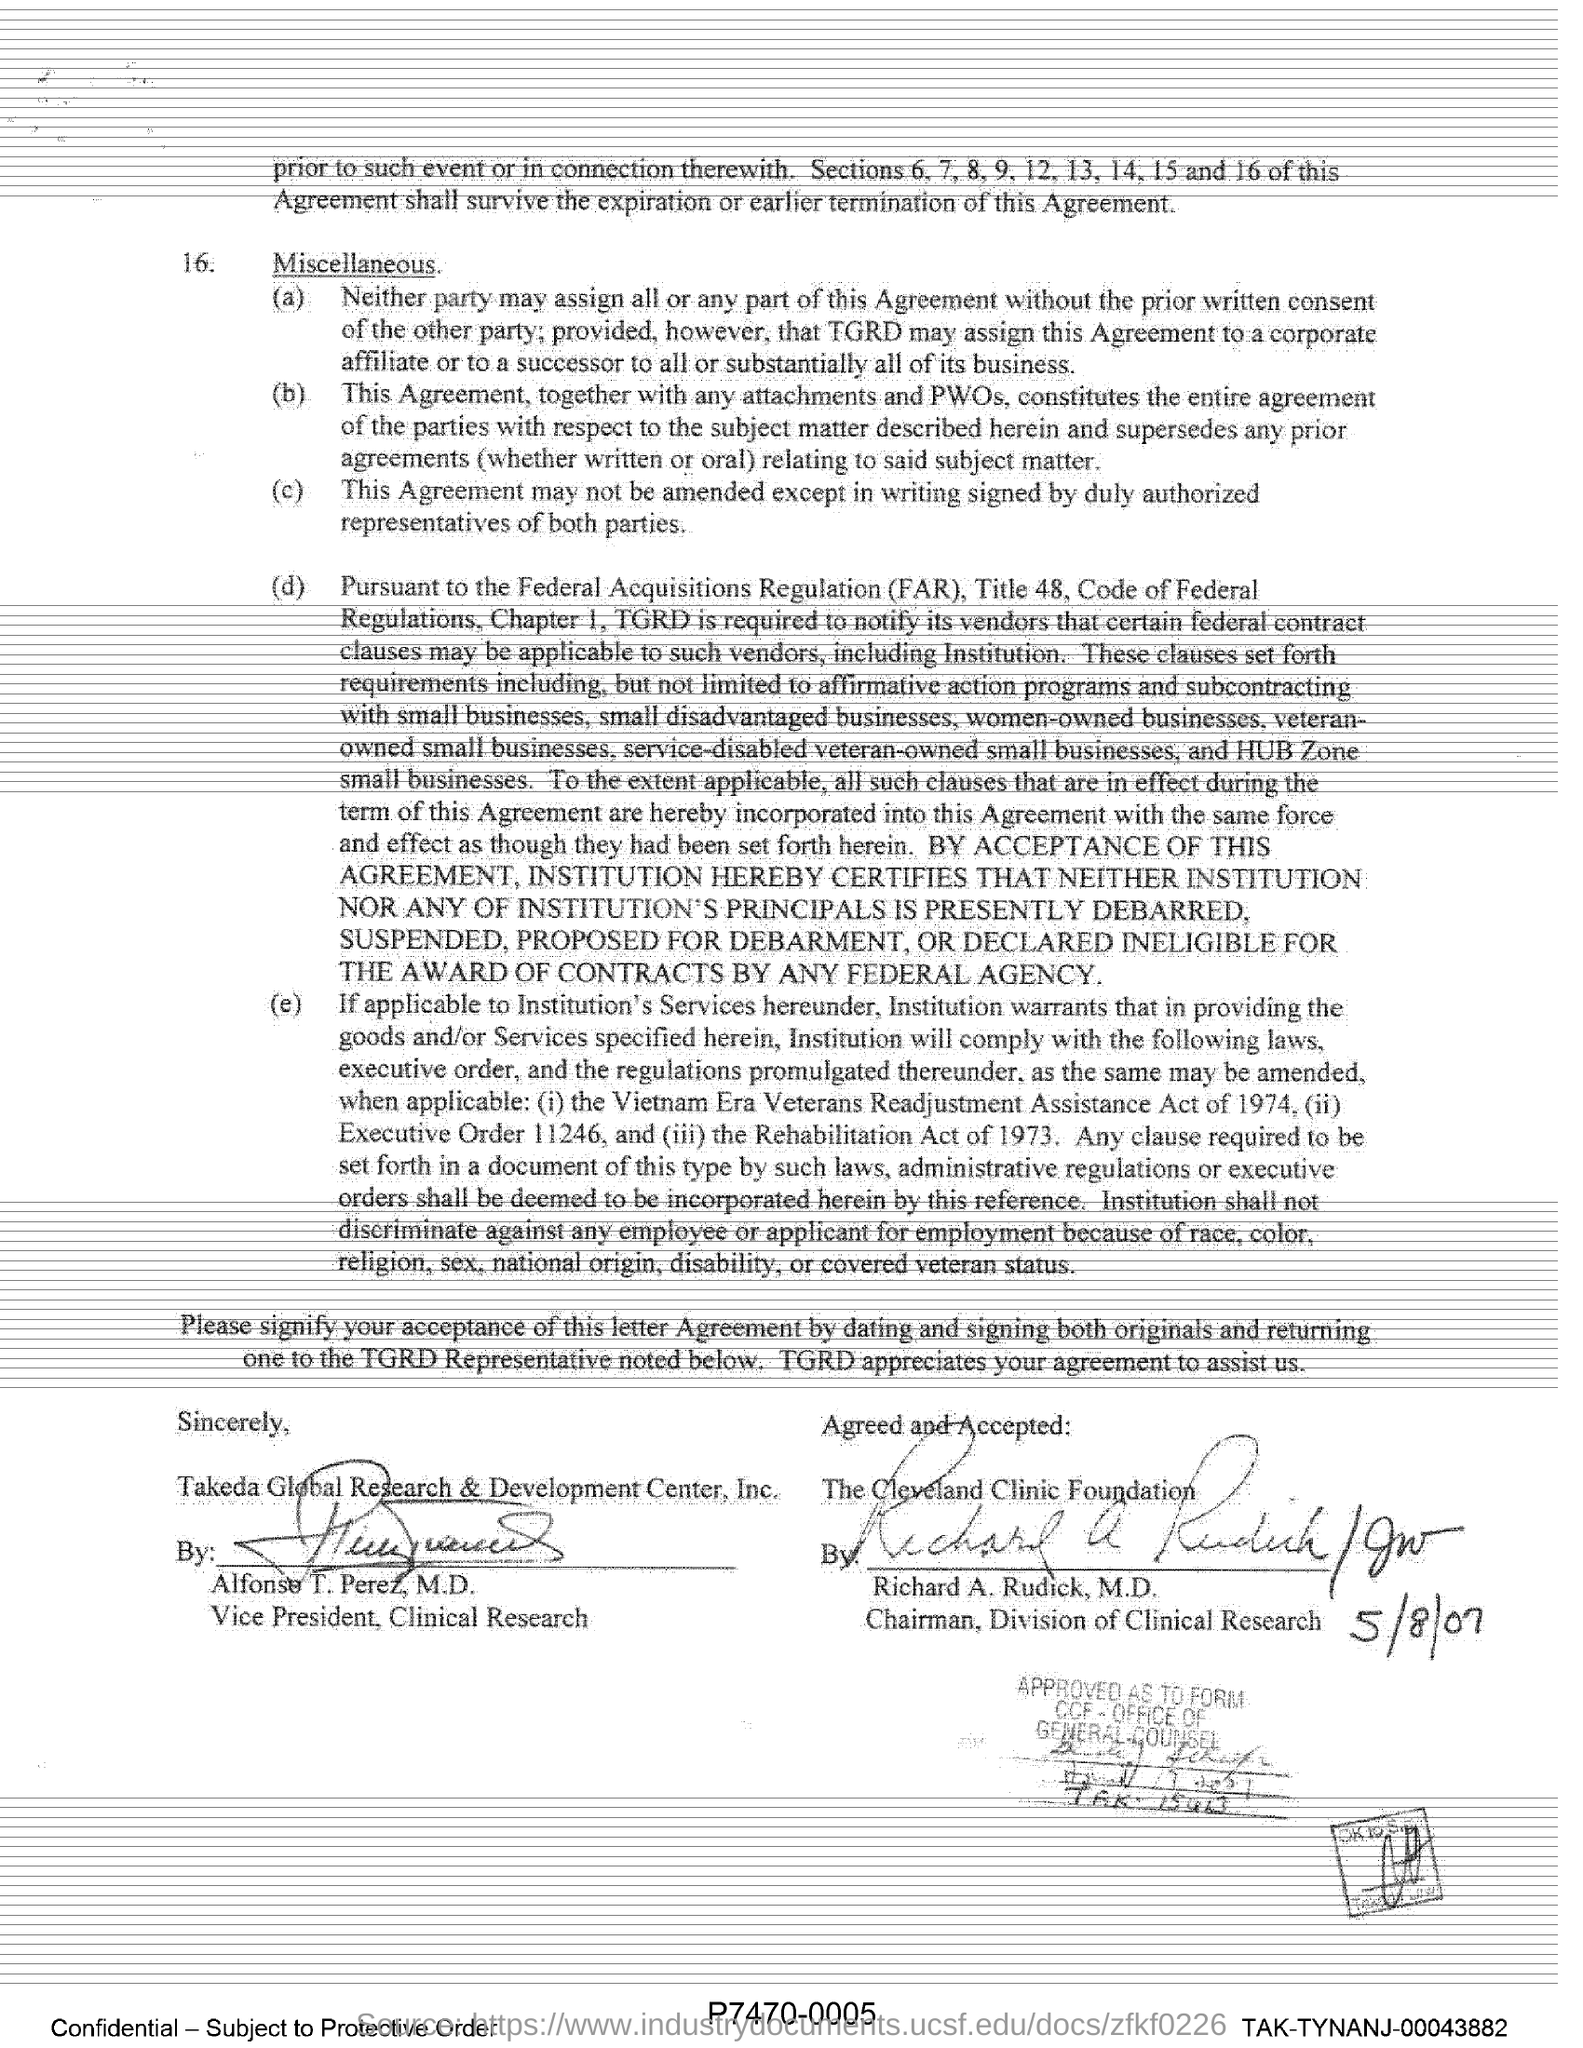Specify some key components in this picture. Alfonso T. Perez, M.D. is the Vice President of Clinical Research. The agreement was agreed and accepted by Richard A. Rudick. Federal Acquisitions Regulation, commonly abbreviated as FAR, refers to the set of rules and regulations that govern the procurement of goods and services by the federal government of the United States. The signature of the chairman of the Division of clinical research was dated May 8th, 2007. 